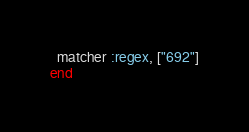Convert code to text. <code><loc_0><loc_0><loc_500><loc_500><_Elixir_>
  matcher :regex, ["692"]
end
</code> 